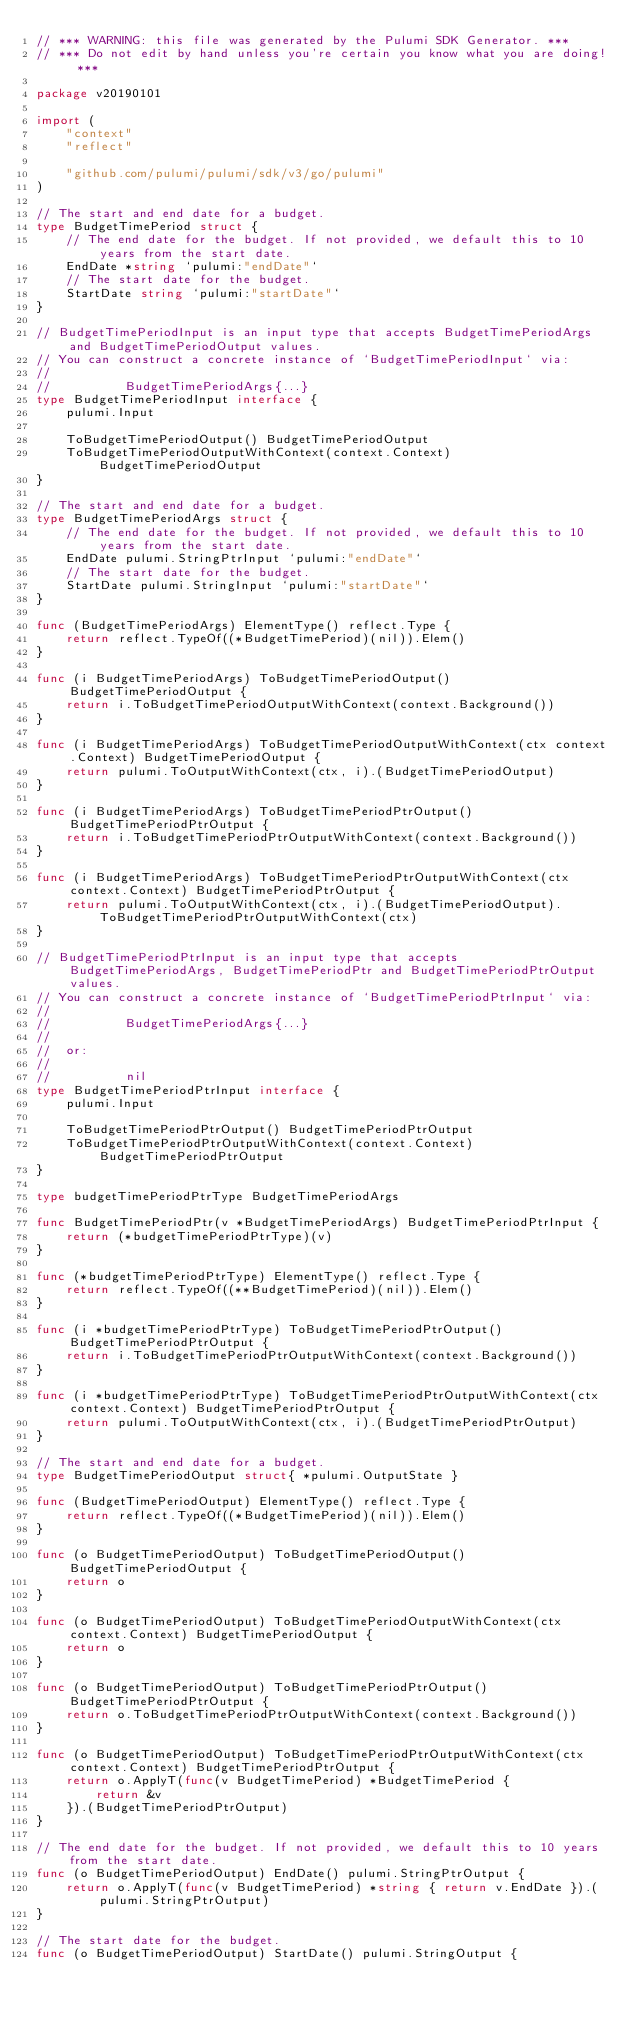Convert code to text. <code><loc_0><loc_0><loc_500><loc_500><_Go_>// *** WARNING: this file was generated by the Pulumi SDK Generator. ***
// *** Do not edit by hand unless you're certain you know what you are doing! ***

package v20190101

import (
	"context"
	"reflect"

	"github.com/pulumi/pulumi/sdk/v3/go/pulumi"
)

// The start and end date for a budget.
type BudgetTimePeriod struct {
	// The end date for the budget. If not provided, we default this to 10 years from the start date.
	EndDate *string `pulumi:"endDate"`
	// The start date for the budget.
	StartDate string `pulumi:"startDate"`
}

// BudgetTimePeriodInput is an input type that accepts BudgetTimePeriodArgs and BudgetTimePeriodOutput values.
// You can construct a concrete instance of `BudgetTimePeriodInput` via:
//
//          BudgetTimePeriodArgs{...}
type BudgetTimePeriodInput interface {
	pulumi.Input

	ToBudgetTimePeriodOutput() BudgetTimePeriodOutput
	ToBudgetTimePeriodOutputWithContext(context.Context) BudgetTimePeriodOutput
}

// The start and end date for a budget.
type BudgetTimePeriodArgs struct {
	// The end date for the budget. If not provided, we default this to 10 years from the start date.
	EndDate pulumi.StringPtrInput `pulumi:"endDate"`
	// The start date for the budget.
	StartDate pulumi.StringInput `pulumi:"startDate"`
}

func (BudgetTimePeriodArgs) ElementType() reflect.Type {
	return reflect.TypeOf((*BudgetTimePeriod)(nil)).Elem()
}

func (i BudgetTimePeriodArgs) ToBudgetTimePeriodOutput() BudgetTimePeriodOutput {
	return i.ToBudgetTimePeriodOutputWithContext(context.Background())
}

func (i BudgetTimePeriodArgs) ToBudgetTimePeriodOutputWithContext(ctx context.Context) BudgetTimePeriodOutput {
	return pulumi.ToOutputWithContext(ctx, i).(BudgetTimePeriodOutput)
}

func (i BudgetTimePeriodArgs) ToBudgetTimePeriodPtrOutput() BudgetTimePeriodPtrOutput {
	return i.ToBudgetTimePeriodPtrOutputWithContext(context.Background())
}

func (i BudgetTimePeriodArgs) ToBudgetTimePeriodPtrOutputWithContext(ctx context.Context) BudgetTimePeriodPtrOutput {
	return pulumi.ToOutputWithContext(ctx, i).(BudgetTimePeriodOutput).ToBudgetTimePeriodPtrOutputWithContext(ctx)
}

// BudgetTimePeriodPtrInput is an input type that accepts BudgetTimePeriodArgs, BudgetTimePeriodPtr and BudgetTimePeriodPtrOutput values.
// You can construct a concrete instance of `BudgetTimePeriodPtrInput` via:
//
//          BudgetTimePeriodArgs{...}
//
//  or:
//
//          nil
type BudgetTimePeriodPtrInput interface {
	pulumi.Input

	ToBudgetTimePeriodPtrOutput() BudgetTimePeriodPtrOutput
	ToBudgetTimePeriodPtrOutputWithContext(context.Context) BudgetTimePeriodPtrOutput
}

type budgetTimePeriodPtrType BudgetTimePeriodArgs

func BudgetTimePeriodPtr(v *BudgetTimePeriodArgs) BudgetTimePeriodPtrInput {
	return (*budgetTimePeriodPtrType)(v)
}

func (*budgetTimePeriodPtrType) ElementType() reflect.Type {
	return reflect.TypeOf((**BudgetTimePeriod)(nil)).Elem()
}

func (i *budgetTimePeriodPtrType) ToBudgetTimePeriodPtrOutput() BudgetTimePeriodPtrOutput {
	return i.ToBudgetTimePeriodPtrOutputWithContext(context.Background())
}

func (i *budgetTimePeriodPtrType) ToBudgetTimePeriodPtrOutputWithContext(ctx context.Context) BudgetTimePeriodPtrOutput {
	return pulumi.ToOutputWithContext(ctx, i).(BudgetTimePeriodPtrOutput)
}

// The start and end date for a budget.
type BudgetTimePeriodOutput struct{ *pulumi.OutputState }

func (BudgetTimePeriodOutput) ElementType() reflect.Type {
	return reflect.TypeOf((*BudgetTimePeriod)(nil)).Elem()
}

func (o BudgetTimePeriodOutput) ToBudgetTimePeriodOutput() BudgetTimePeriodOutput {
	return o
}

func (o BudgetTimePeriodOutput) ToBudgetTimePeriodOutputWithContext(ctx context.Context) BudgetTimePeriodOutput {
	return o
}

func (o BudgetTimePeriodOutput) ToBudgetTimePeriodPtrOutput() BudgetTimePeriodPtrOutput {
	return o.ToBudgetTimePeriodPtrOutputWithContext(context.Background())
}

func (o BudgetTimePeriodOutput) ToBudgetTimePeriodPtrOutputWithContext(ctx context.Context) BudgetTimePeriodPtrOutput {
	return o.ApplyT(func(v BudgetTimePeriod) *BudgetTimePeriod {
		return &v
	}).(BudgetTimePeriodPtrOutput)
}

// The end date for the budget. If not provided, we default this to 10 years from the start date.
func (o BudgetTimePeriodOutput) EndDate() pulumi.StringPtrOutput {
	return o.ApplyT(func(v BudgetTimePeriod) *string { return v.EndDate }).(pulumi.StringPtrOutput)
}

// The start date for the budget.
func (o BudgetTimePeriodOutput) StartDate() pulumi.StringOutput {</code> 